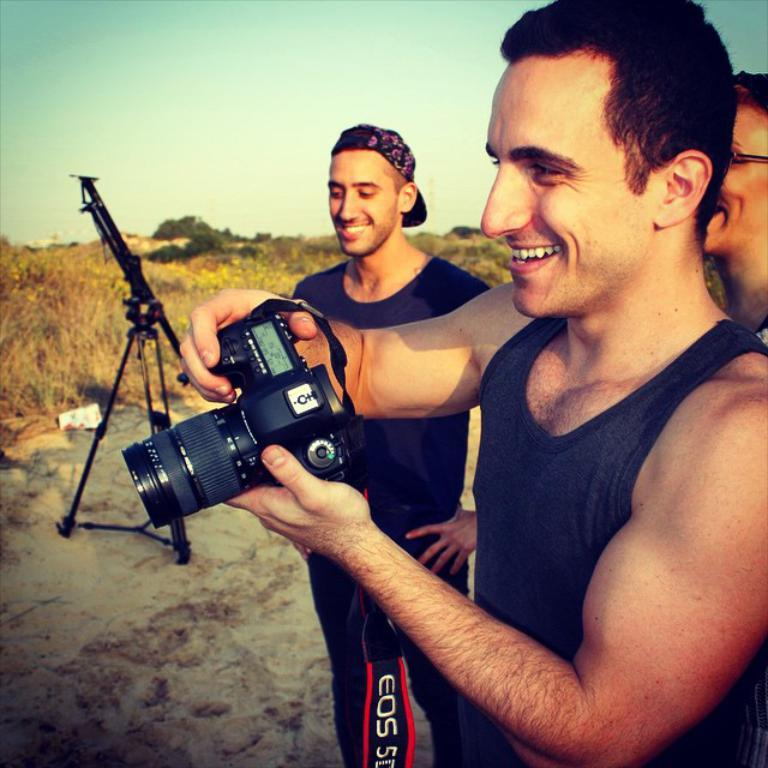How many people are in the image? There are three persons standing in the image. What is one person doing with his hands? One person is holding a camera in his hands. What can be seen in the background of the image? There is a stand and plants in the background of the image. What is visible in the sky in the image? The sky is visible in the background of the image. What is the cause of the elbow pain experienced by one of the persons in the image? There is no mention of elbow pain or any medical condition in the image. 